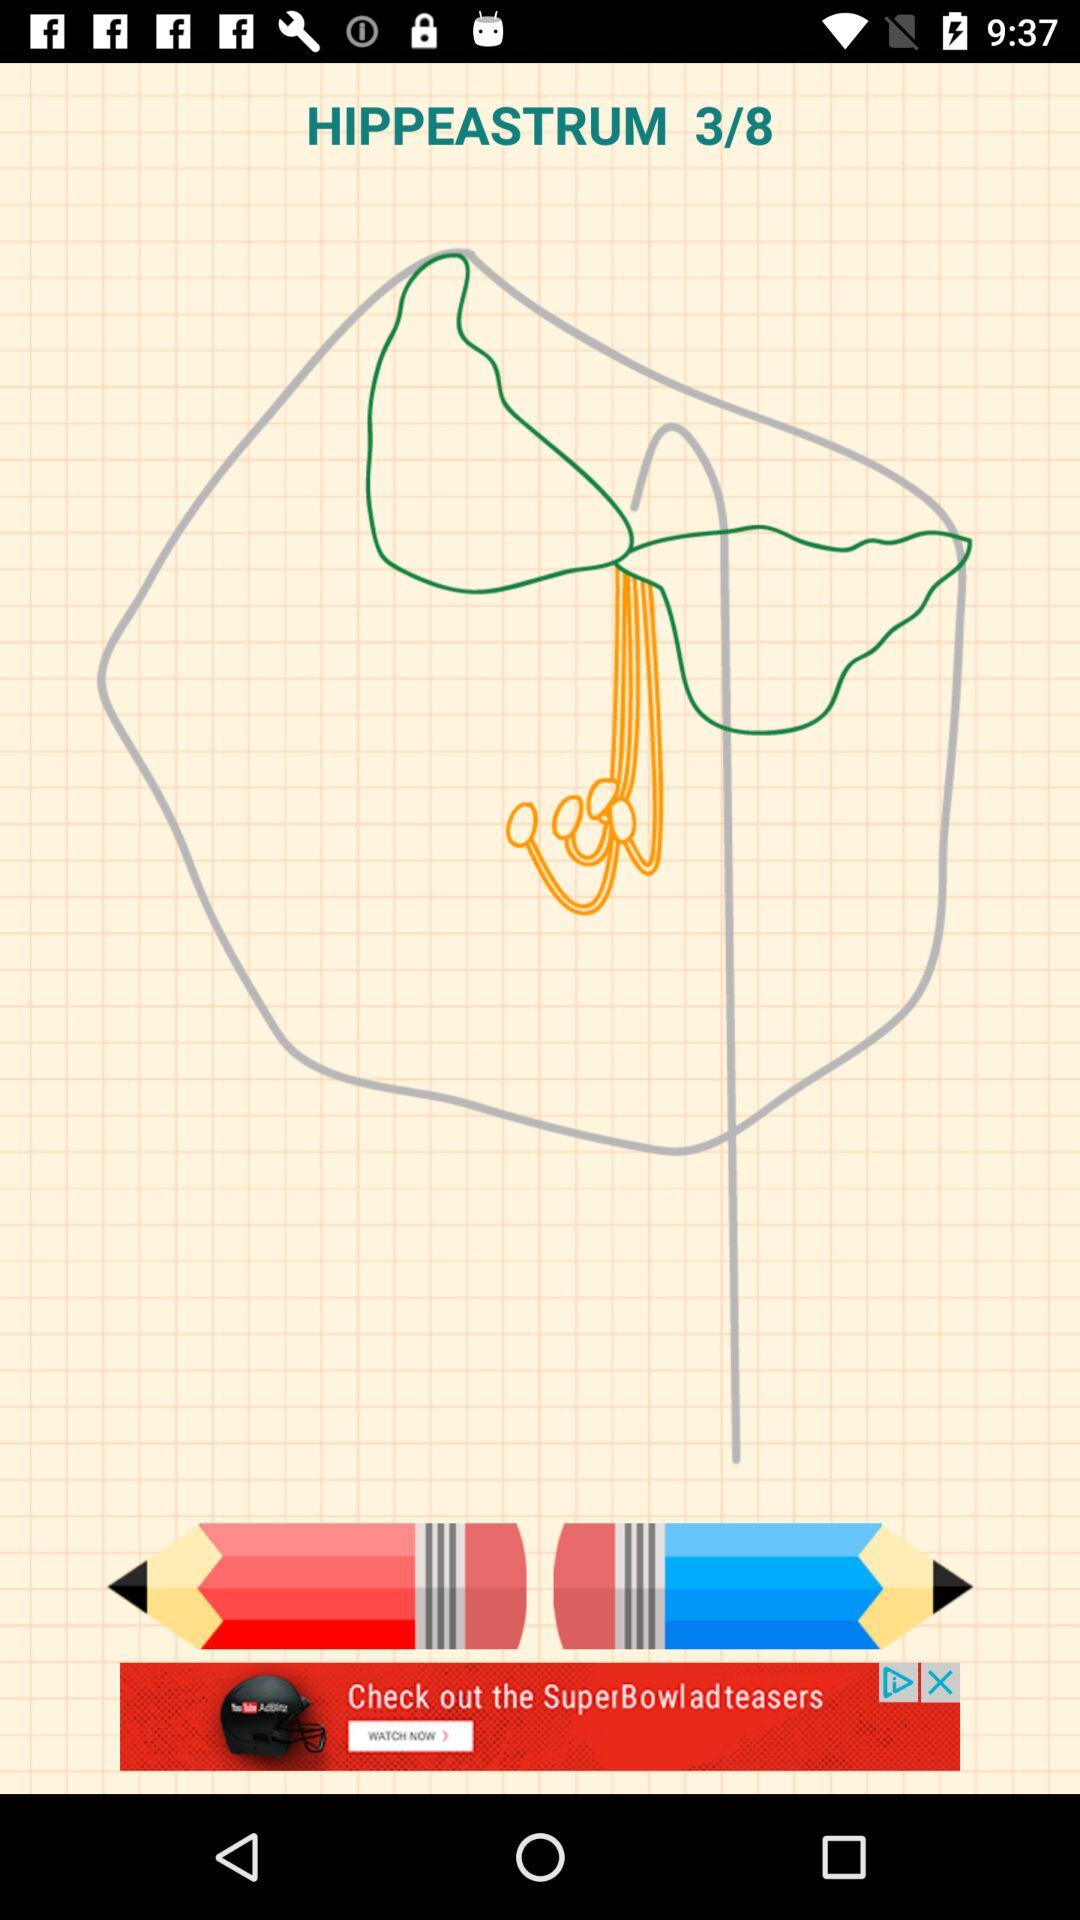What step number am I on? You are on step number 3. 